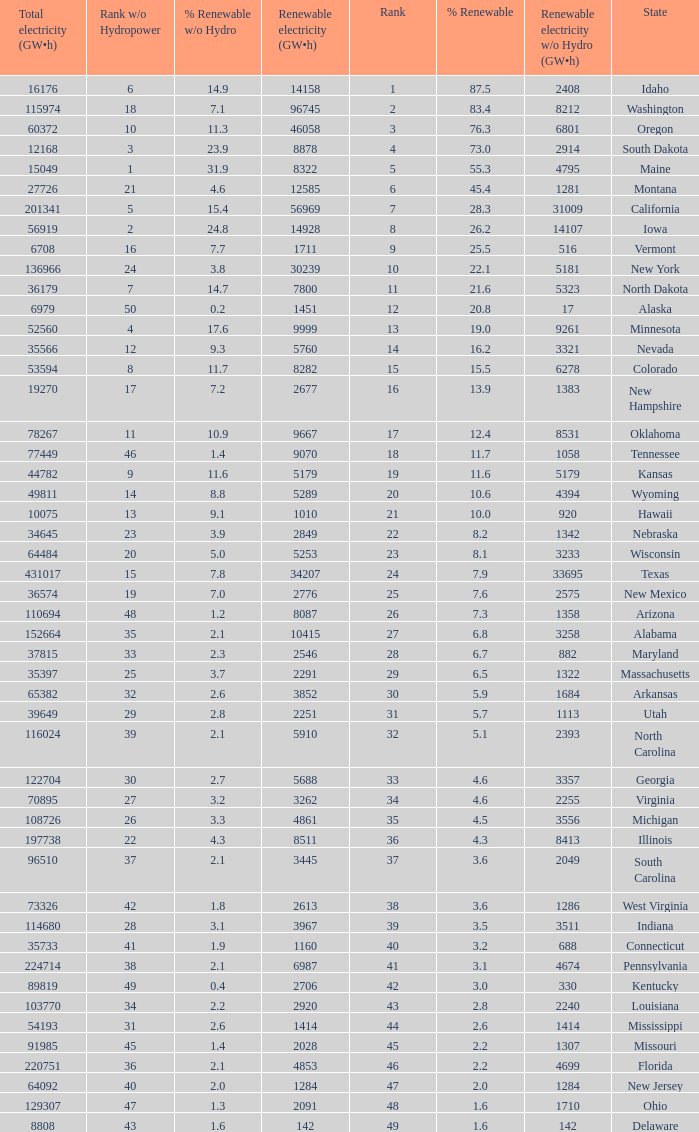Which states have renewable electricity equal to 9667 (gw×h)? Oklahoma. 